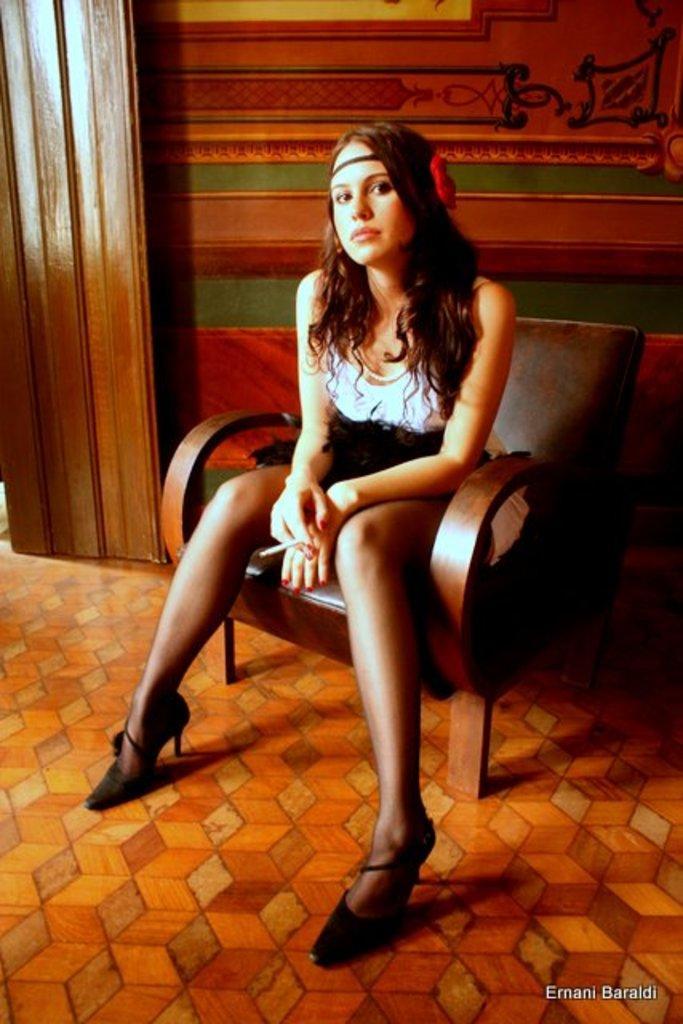In one or two sentences, can you explain what this image depicts? In the picture we can see women wearing white and black color dress sitting on a chair and in the background there is a wall. 